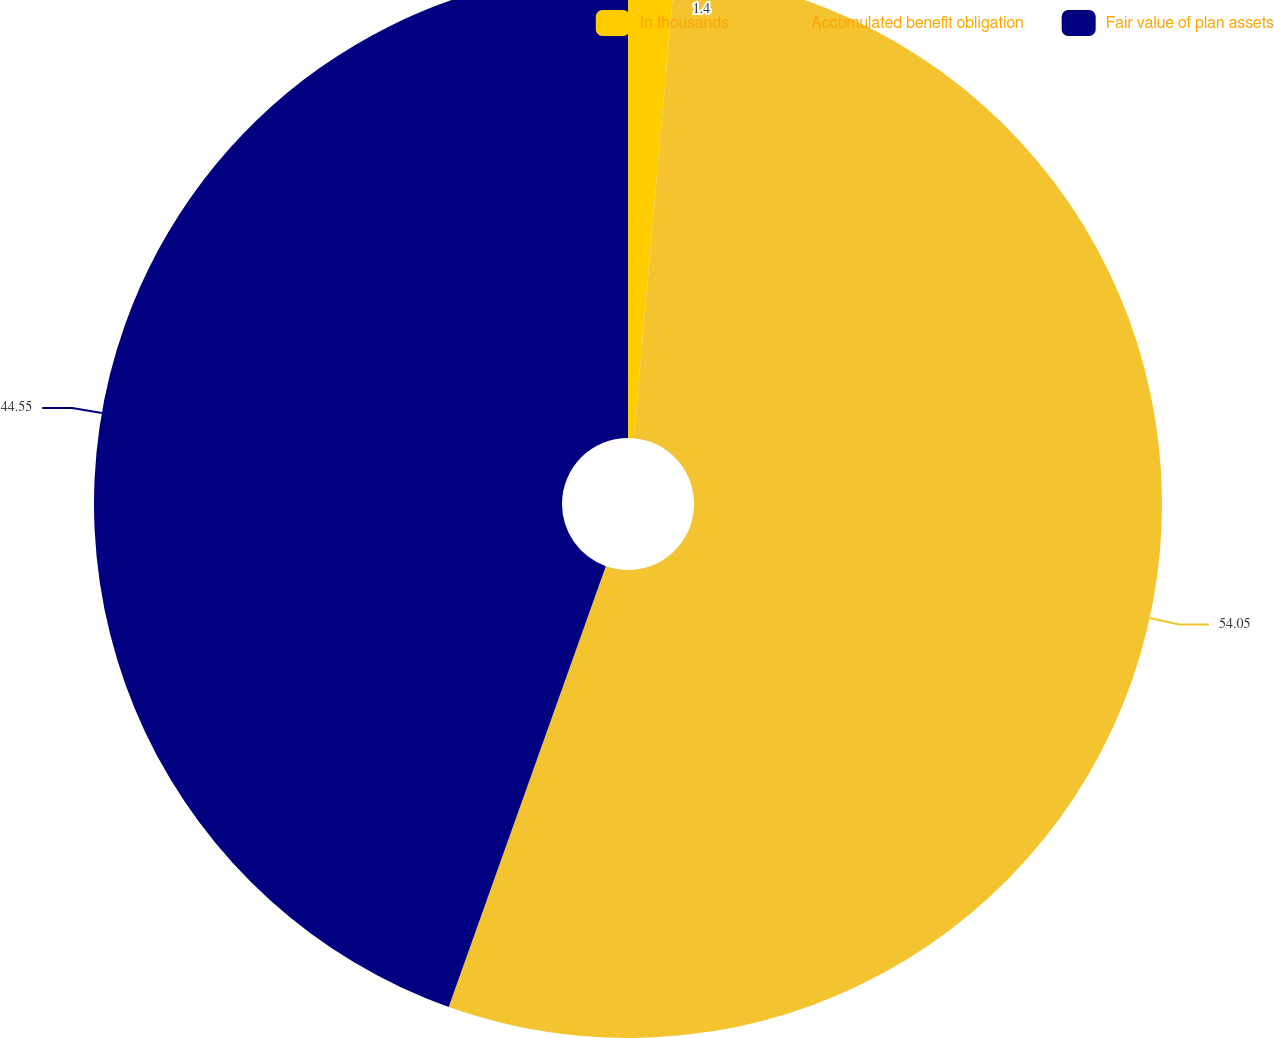<chart> <loc_0><loc_0><loc_500><loc_500><pie_chart><fcel>In thousands<fcel>Accumulated benefit obligation<fcel>Fair value of plan assets<nl><fcel>1.4%<fcel>54.05%<fcel>44.55%<nl></chart> 